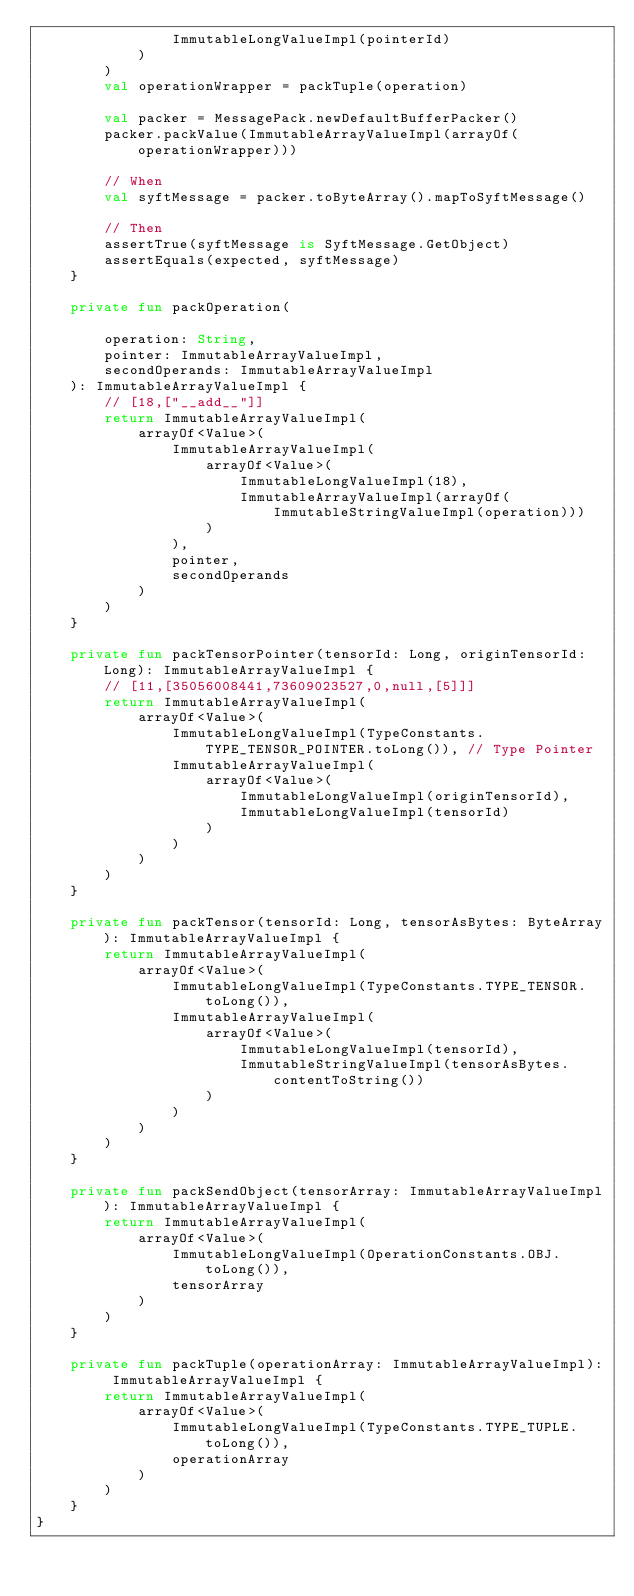<code> <loc_0><loc_0><loc_500><loc_500><_Kotlin_>                ImmutableLongValueImpl(pointerId)
            )
        )
        val operationWrapper = packTuple(operation)

        val packer = MessagePack.newDefaultBufferPacker()
        packer.packValue(ImmutableArrayValueImpl(arrayOf(operationWrapper)))

        // When
        val syftMessage = packer.toByteArray().mapToSyftMessage()

        // Then
        assertTrue(syftMessage is SyftMessage.GetObject)
        assertEquals(expected, syftMessage)
    }

    private fun packOperation(

        operation: String,
        pointer: ImmutableArrayValueImpl,
        secondOperands: ImmutableArrayValueImpl
    ): ImmutableArrayValueImpl {
        // [18,["__add__"]]
        return ImmutableArrayValueImpl(
            arrayOf<Value>(
                ImmutableArrayValueImpl(
                    arrayOf<Value>(
                        ImmutableLongValueImpl(18),
                        ImmutableArrayValueImpl(arrayOf(ImmutableStringValueImpl(operation)))
                    )
                ),
                pointer,
                secondOperands
            )
        )
    }

    private fun packTensorPointer(tensorId: Long, originTensorId: Long): ImmutableArrayValueImpl {
        // [11,[35056008441,73609023527,0,null,[5]]]
        return ImmutableArrayValueImpl(
            arrayOf<Value>(
                ImmutableLongValueImpl(TypeConstants.TYPE_TENSOR_POINTER.toLong()), // Type Pointer
                ImmutableArrayValueImpl(
                    arrayOf<Value>(
                        ImmutableLongValueImpl(originTensorId),
                        ImmutableLongValueImpl(tensorId)
                    )
                )
            )
        )
    }

    private fun packTensor(tensorId: Long, tensorAsBytes: ByteArray): ImmutableArrayValueImpl {
        return ImmutableArrayValueImpl(
            arrayOf<Value>(
                ImmutableLongValueImpl(TypeConstants.TYPE_TENSOR.toLong()),
                ImmutableArrayValueImpl(
                    arrayOf<Value>(
                        ImmutableLongValueImpl(tensorId),
                        ImmutableStringValueImpl(tensorAsBytes.contentToString())
                    )
                )
            )
        )
    }

    private fun packSendObject(tensorArray: ImmutableArrayValueImpl): ImmutableArrayValueImpl {
        return ImmutableArrayValueImpl(
            arrayOf<Value>(
                ImmutableLongValueImpl(OperationConstants.OBJ.toLong()),
                tensorArray
            )
        )
    }

    private fun packTuple(operationArray: ImmutableArrayValueImpl): ImmutableArrayValueImpl {
        return ImmutableArrayValueImpl(
            arrayOf<Value>(
                ImmutableLongValueImpl(TypeConstants.TYPE_TUPLE.toLong()),
                operationArray
            )
        )
    }
}</code> 